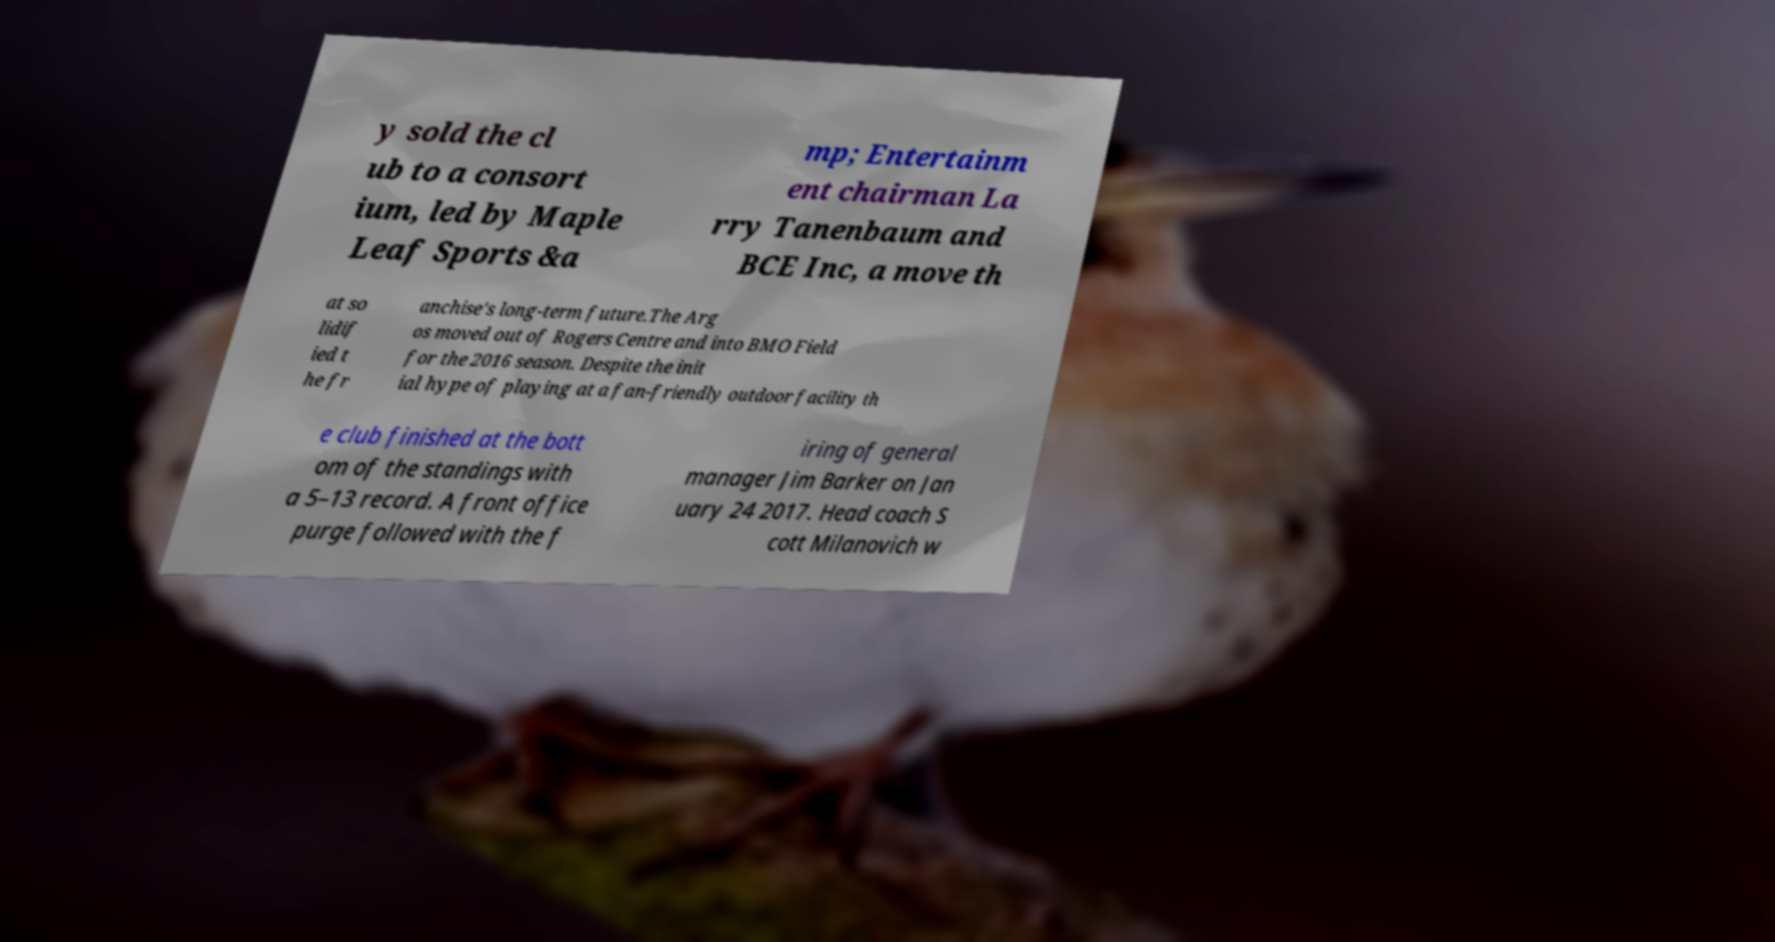What messages or text are displayed in this image? I need them in a readable, typed format. y sold the cl ub to a consort ium, led by Maple Leaf Sports &a mp; Entertainm ent chairman La rry Tanenbaum and BCE Inc, a move th at so lidif ied t he fr anchise's long-term future.The Arg os moved out of Rogers Centre and into BMO Field for the 2016 season. Despite the init ial hype of playing at a fan-friendly outdoor facility th e club finished at the bott om of the standings with a 5–13 record. A front office purge followed with the f iring of general manager Jim Barker on Jan uary 24 2017. Head coach S cott Milanovich w 